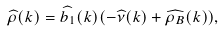<formula> <loc_0><loc_0><loc_500><loc_500>\widehat { \rho } ( k ) = \widehat { b _ { 1 } } ( k ) ( - \widehat { \nu } ( k ) + \widehat { \rho _ { B } } ( k ) ) ,</formula> 